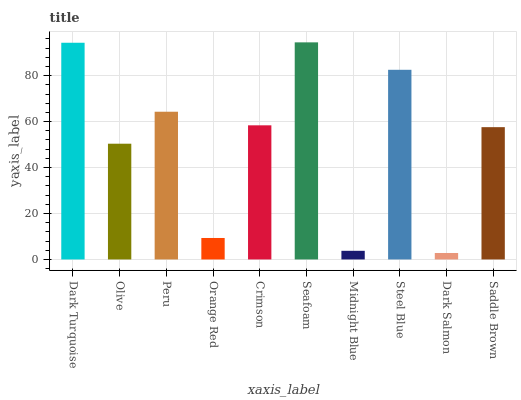Is Dark Salmon the minimum?
Answer yes or no. Yes. Is Seafoam the maximum?
Answer yes or no. Yes. Is Olive the minimum?
Answer yes or no. No. Is Olive the maximum?
Answer yes or no. No. Is Dark Turquoise greater than Olive?
Answer yes or no. Yes. Is Olive less than Dark Turquoise?
Answer yes or no. Yes. Is Olive greater than Dark Turquoise?
Answer yes or no. No. Is Dark Turquoise less than Olive?
Answer yes or no. No. Is Crimson the high median?
Answer yes or no. Yes. Is Saddle Brown the low median?
Answer yes or no. Yes. Is Olive the high median?
Answer yes or no. No. Is Dark Salmon the low median?
Answer yes or no. No. 